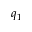<formula> <loc_0><loc_0><loc_500><loc_500>q _ { 1 }</formula> 